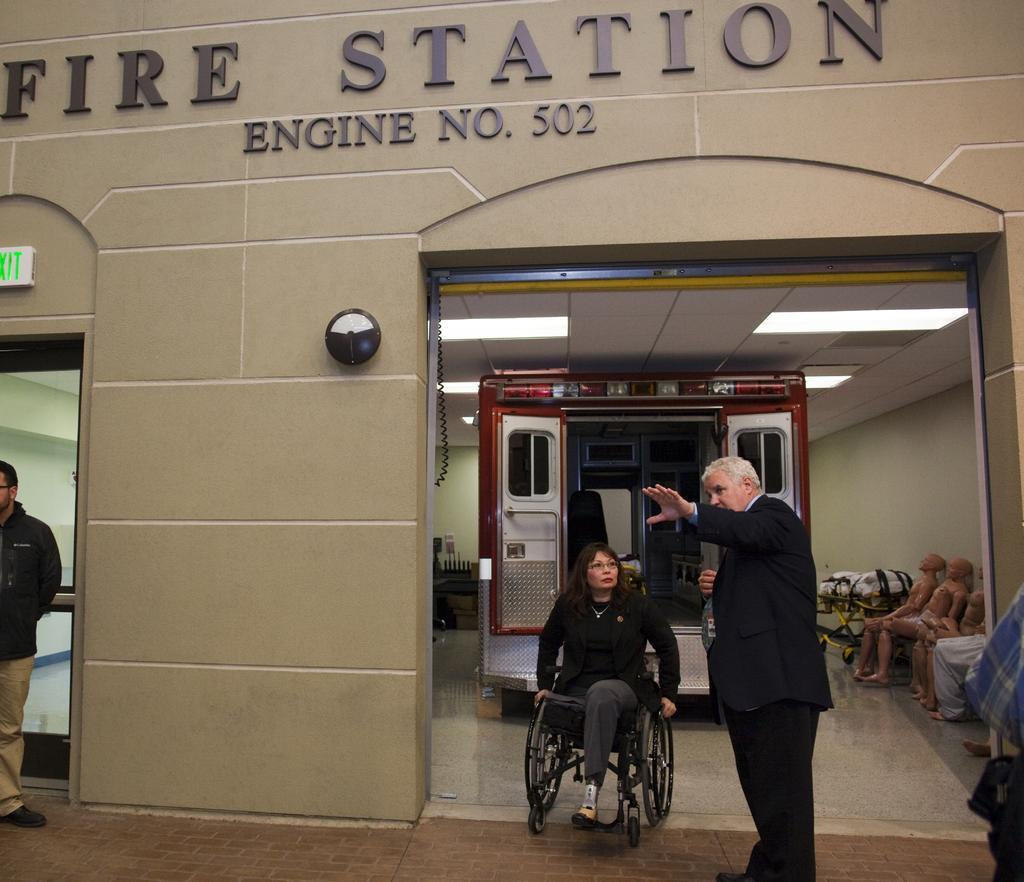In one or two sentences, can you explain what this image depicts? In this image I can see three persons are sitting on the chairs and two persons are standing on the floor. In the background I can see a wall, doors, text, lights on a rooftop and so on. This image is taken may be in a hall. 